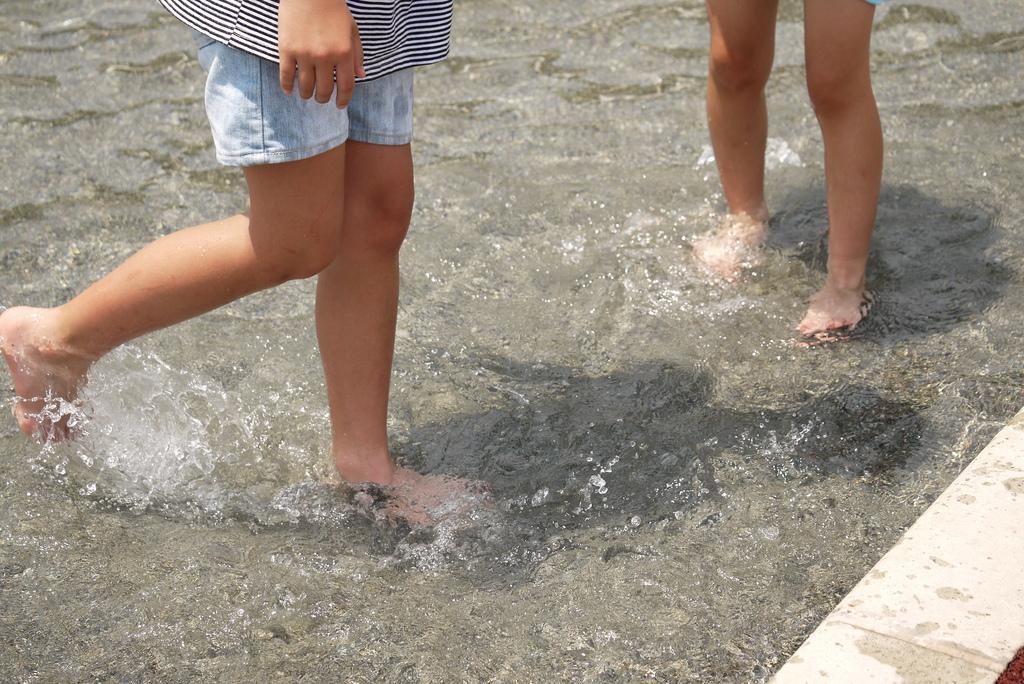Please provide a concise description of this image. This picture shows couple of human in the water we see their legs and a hand. 